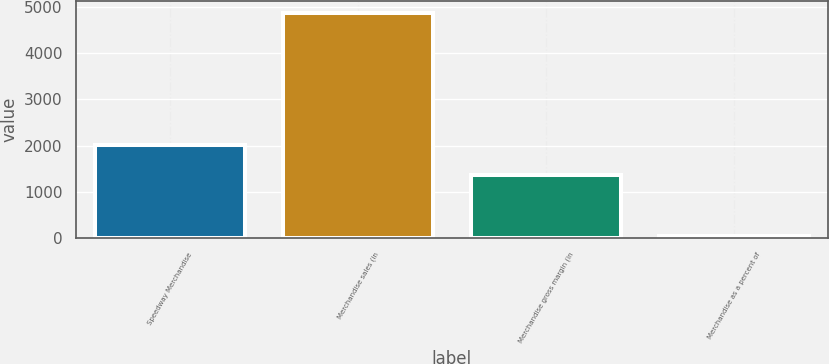<chart> <loc_0><loc_0><loc_500><loc_500><bar_chart><fcel>Speedway Merchandise<fcel>Merchandise sales (in<fcel>Merchandise gross margin (in<fcel>Merchandise as a percent of<nl><fcel>2015<fcel>4879<fcel>1368<fcel>54<nl></chart> 